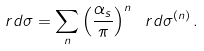<formula> <loc_0><loc_0><loc_500><loc_500>\ r d \sigma = \sum _ { n } \left ( \frac { \alpha _ { s } } { \pi } \right ) ^ { n } \ r d \sigma ^ { ( n ) } \, .</formula> 